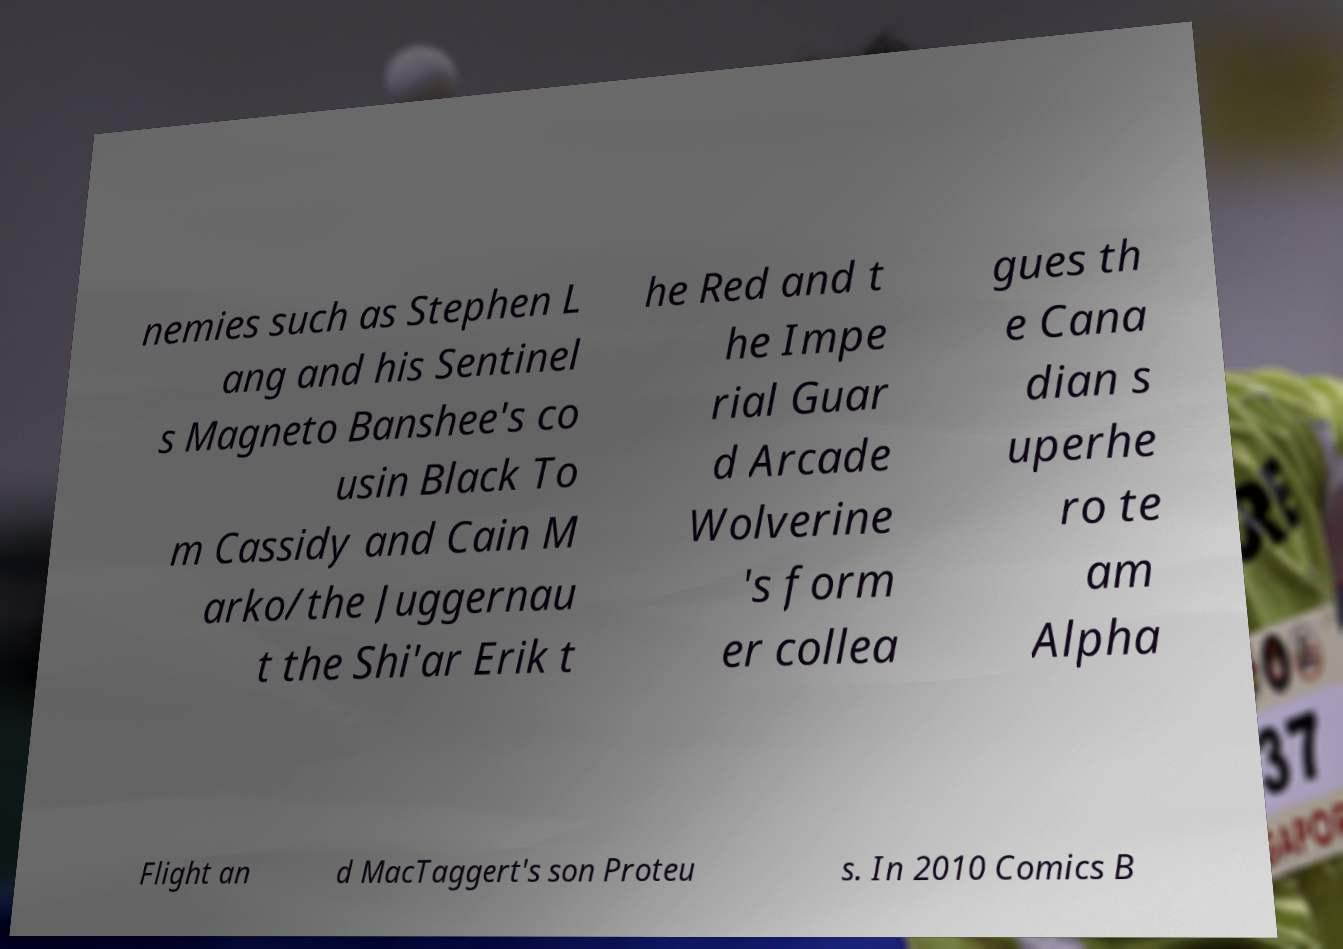What messages or text are displayed in this image? I need them in a readable, typed format. nemies such as Stephen L ang and his Sentinel s Magneto Banshee's co usin Black To m Cassidy and Cain M arko/the Juggernau t the Shi'ar Erik t he Red and t he Impe rial Guar d Arcade Wolverine 's form er collea gues th e Cana dian s uperhe ro te am Alpha Flight an d MacTaggert's son Proteu s. In 2010 Comics B 